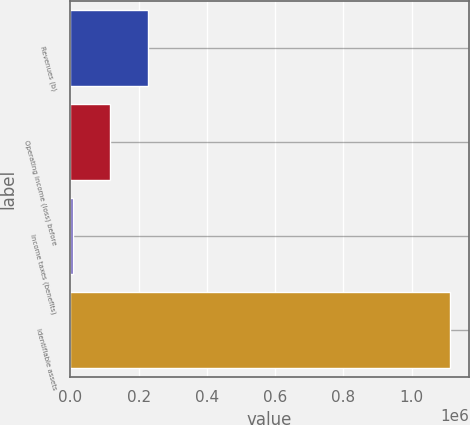Convert chart. <chart><loc_0><loc_0><loc_500><loc_500><bar_chart><fcel>Revenues (b)<fcel>Operating income (loss) before<fcel>Income taxes (benefits)<fcel>Identifiable assets<nl><fcel>227612<fcel>117062<fcel>6511<fcel>1.11202e+06<nl></chart> 